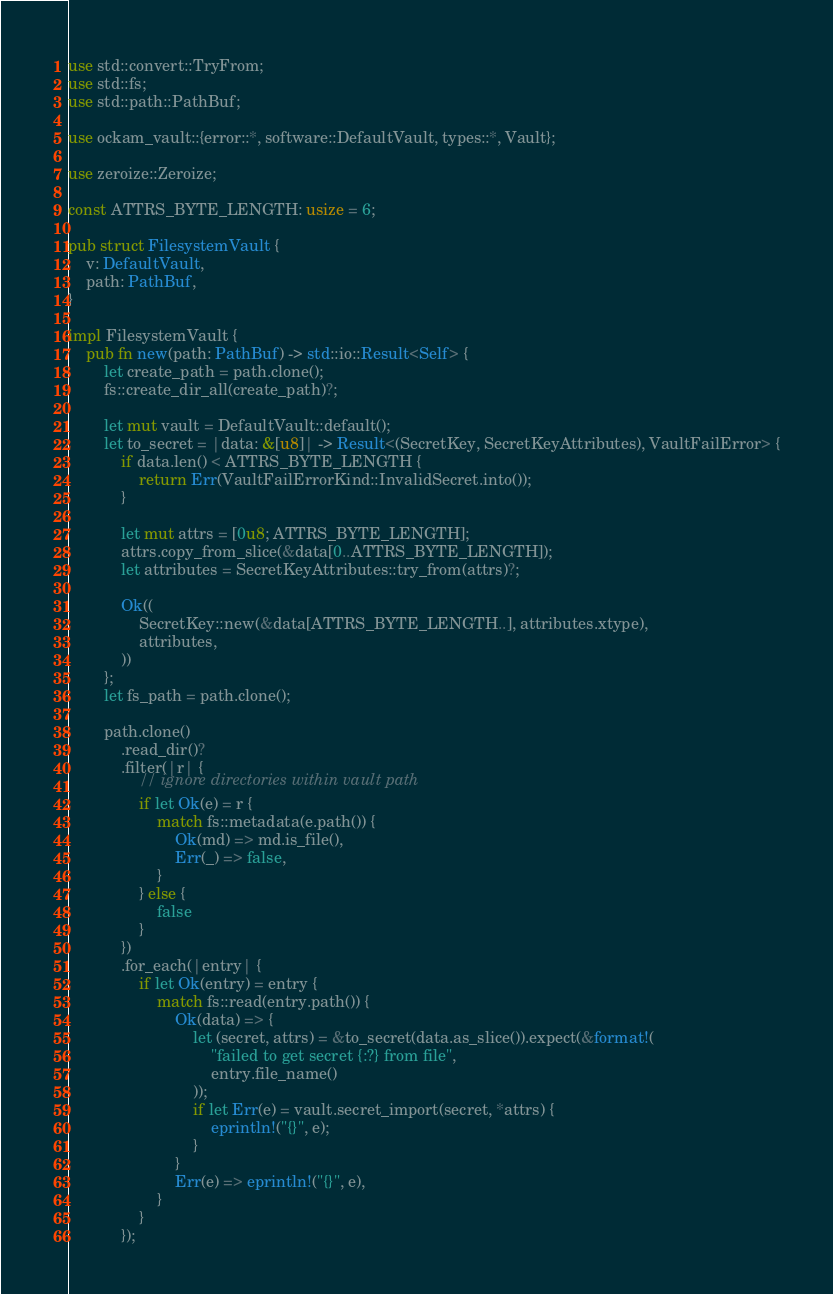Convert code to text. <code><loc_0><loc_0><loc_500><loc_500><_Rust_>use std::convert::TryFrom;
use std::fs;
use std::path::PathBuf;

use ockam_vault::{error::*, software::DefaultVault, types::*, Vault};

use zeroize::Zeroize;

const ATTRS_BYTE_LENGTH: usize = 6;

pub struct FilesystemVault {
    v: DefaultVault,
    path: PathBuf,
}

impl FilesystemVault {
    pub fn new(path: PathBuf) -> std::io::Result<Self> {
        let create_path = path.clone();
        fs::create_dir_all(create_path)?;

        let mut vault = DefaultVault::default();
        let to_secret = |data: &[u8]| -> Result<(SecretKey, SecretKeyAttributes), VaultFailError> {
            if data.len() < ATTRS_BYTE_LENGTH {
                return Err(VaultFailErrorKind::InvalidSecret.into());
            }

            let mut attrs = [0u8; ATTRS_BYTE_LENGTH];
            attrs.copy_from_slice(&data[0..ATTRS_BYTE_LENGTH]);
            let attributes = SecretKeyAttributes::try_from(attrs)?;

            Ok((
                SecretKey::new(&data[ATTRS_BYTE_LENGTH..], attributes.xtype),
                attributes,
            ))
        };
        let fs_path = path.clone();

        path.clone()
            .read_dir()?
            .filter(|r| {
                // ignore directories within vault path
                if let Ok(e) = r {
                    match fs::metadata(e.path()) {
                        Ok(md) => md.is_file(),
                        Err(_) => false,
                    }
                } else {
                    false
                }
            })
            .for_each(|entry| {
                if let Ok(entry) = entry {
                    match fs::read(entry.path()) {
                        Ok(data) => {
                            let (secret, attrs) = &to_secret(data.as_slice()).expect(&format!(
                                "failed to get secret {:?} from file",
                                entry.file_name()
                            ));
                            if let Err(e) = vault.secret_import(secret, *attrs) {
                                eprintln!("{}", e);
                            }
                        }
                        Err(e) => eprintln!("{}", e),
                    }
                }
            });
</code> 